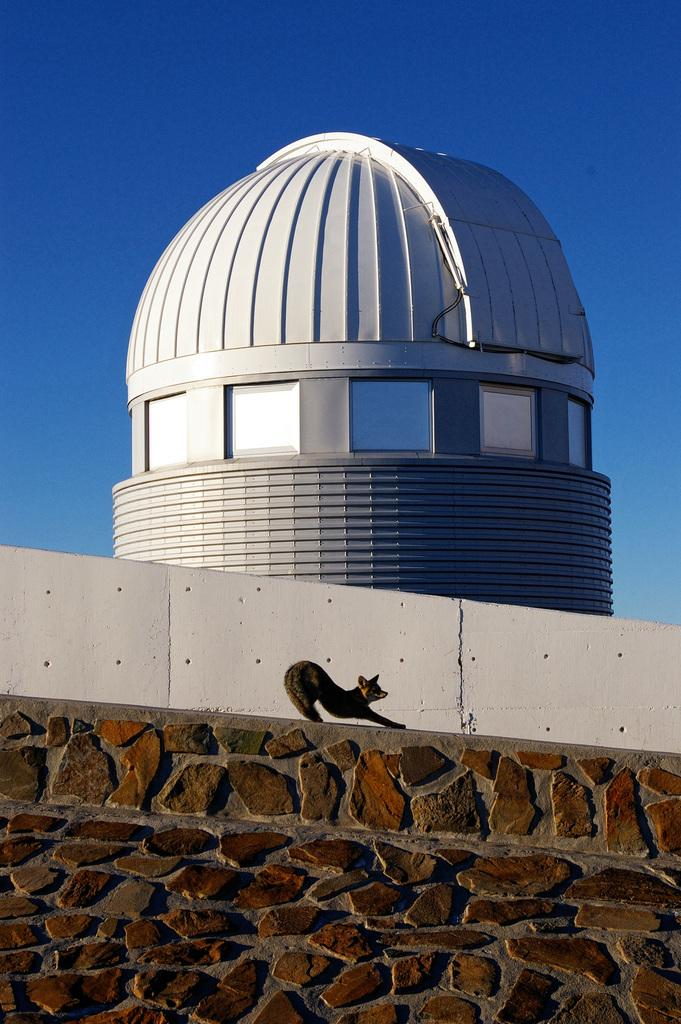What is the color of the architecture in the image? The architecture in the image is white in color. What can be seen on the side of the architecture? There is a wall visible in the image. What type of living creature is present in the image? An animal is present in the image. What is the color of the sky in the background of the image? The sky is blue in the background of the image. What type of celery is being used for arithmetic in the image? There is no celery or arithmetic present in the image. Can you tell me what your dad is doing in the image? There is no reference to a dad or any person in the image, so it's not possible to answer that question. 